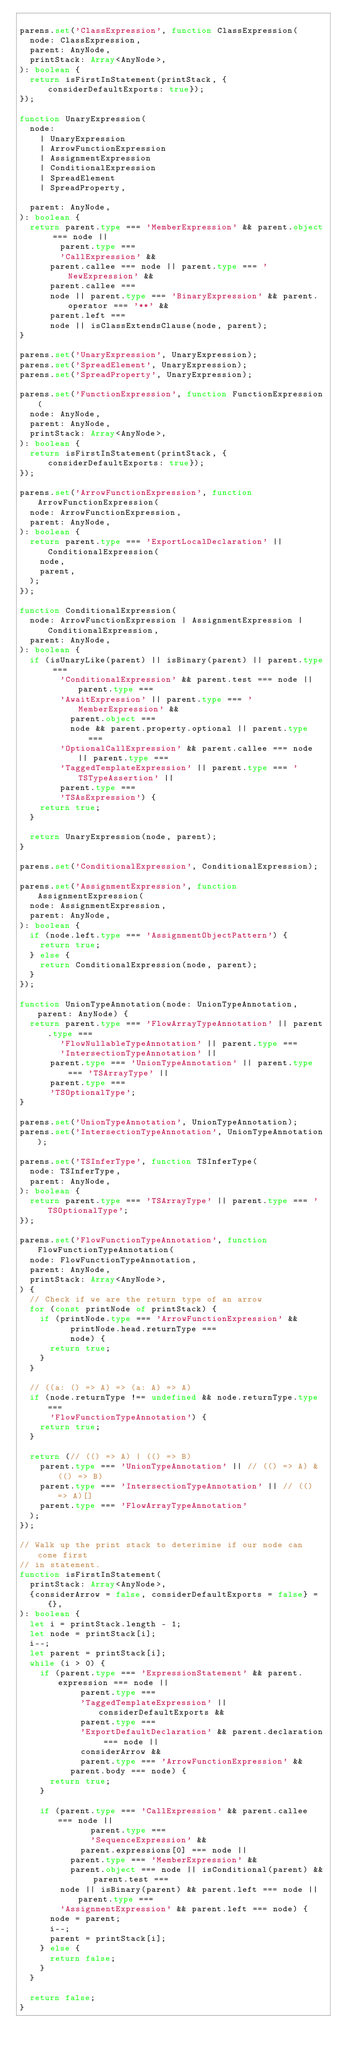Convert code to text. <code><loc_0><loc_0><loc_500><loc_500><_TypeScript_>
parens.set('ClassExpression', function ClassExpression(
  node: ClassExpression,
  parent: AnyNode,
  printStack: Array<AnyNode>,
): boolean {
  return isFirstInStatement(printStack, {considerDefaultExports: true});
});

function UnaryExpression(
  node:
    | UnaryExpression
    | ArrowFunctionExpression
    | AssignmentExpression
    | ConditionalExpression
    | SpreadElement
    | SpreadProperty,

  parent: AnyNode,
): boolean {
  return parent.type === 'MemberExpression' && parent.object === node ||
        parent.type ===
        'CallExpression' &&
      parent.callee === node || parent.type === 'NewExpression' &&
      parent.callee ===
      node || parent.type === 'BinaryExpression' && parent.operator === '**' &&
      parent.left ===
      node || isClassExtendsClause(node, parent);
}

parens.set('UnaryExpression', UnaryExpression);
parens.set('SpreadElement', UnaryExpression);
parens.set('SpreadProperty', UnaryExpression);

parens.set('FunctionExpression', function FunctionExpression(
  node: AnyNode,
  parent: AnyNode,
  printStack: Array<AnyNode>,
): boolean {
  return isFirstInStatement(printStack, {considerDefaultExports: true});
});

parens.set('ArrowFunctionExpression', function ArrowFunctionExpression(
  node: ArrowFunctionExpression,
  parent: AnyNode,
): boolean {
  return parent.type === 'ExportLocalDeclaration' || ConditionalExpression(
    node,
    parent,
  );
});

function ConditionalExpression(
  node: ArrowFunctionExpression | AssignmentExpression | ConditionalExpression,
  parent: AnyNode,
): boolean {
  if (isUnaryLike(parent) || isBinary(parent) || parent.type ===
        'ConditionalExpression' && parent.test === node || parent.type ===
        'AwaitExpression' || parent.type === 'MemberExpression' &&
          parent.object ===
          node && parent.property.optional || parent.type ===
        'OptionalCallExpression' && parent.callee === node || parent.type ===
        'TaggedTemplateExpression' || parent.type === 'TSTypeAssertion' ||
        parent.type ===
        'TSAsExpression') {
    return true;
  }

  return UnaryExpression(node, parent);
}

parens.set('ConditionalExpression', ConditionalExpression);

parens.set('AssignmentExpression', function AssignmentExpression(
  node: AssignmentExpression,
  parent: AnyNode,
): boolean {
  if (node.left.type === 'AssignmentObjectPattern') {
    return true;
  } else {
    return ConditionalExpression(node, parent);
  }
});

function UnionTypeAnnotation(node: UnionTypeAnnotation, parent: AnyNode) {
  return parent.type === 'FlowArrayTypeAnnotation' || parent.type ===
        'FlowNullableTypeAnnotation' || parent.type ===
        'IntersectionTypeAnnotation' ||
      parent.type === 'UnionTypeAnnotation' || parent.type === 'TSArrayType' ||
      parent.type ===
      'TSOptionalType';
}

parens.set('UnionTypeAnnotation', UnionTypeAnnotation);
parens.set('IntersectionTypeAnnotation', UnionTypeAnnotation);

parens.set('TSInferType', function TSInferType(
  node: TSInferType,
  parent: AnyNode,
): boolean {
  return parent.type === 'TSArrayType' || parent.type === 'TSOptionalType';
});

parens.set('FlowFunctionTypeAnnotation', function FlowFunctionTypeAnnotation(
  node: FlowFunctionTypeAnnotation,
  parent: AnyNode,
  printStack: Array<AnyNode>,
) {
  // Check if we are the return type of an arrow
  for (const printNode of printStack) {
    if (printNode.type === 'ArrowFunctionExpression' &&
          printNode.head.returnType ===
          node) {
      return true;
    }
  }

  // ((a: () => A) => (a: A) => A)
  if (node.returnType !== undefined && node.returnType.type ===
      'FlowFunctionTypeAnnotation') {
    return true;
  }

  return (// (() => A) | (() => B)
    parent.type === 'UnionTypeAnnotation' || // (() => A) & (() => B)
    parent.type === 'IntersectionTypeAnnotation' || // (() => A)[]
    parent.type === 'FlowArrayTypeAnnotation'
  );
});

// Walk up the print stack to deterimine if our node can come first
// in statement.
function isFirstInStatement(
  printStack: Array<AnyNode>,
  {considerArrow = false, considerDefaultExports = false} = {},
): boolean {
  let i = printStack.length - 1;
  let node = printStack[i];
  i--;
  let parent = printStack[i];
  while (i > 0) {
    if (parent.type === 'ExpressionStatement' && parent.expression === node ||
            parent.type ===
            'TaggedTemplateExpression' || considerDefaultExports &&
            parent.type ===
            'ExportDefaultDeclaration' && parent.declaration === node ||
            considerArrow &&
            parent.type === 'ArrowFunctionExpression' &&
          parent.body === node) {
      return true;
    }

    if (parent.type === 'CallExpression' && parent.callee === node ||
              parent.type ===
              'SequenceExpression' &&
            parent.expressions[0] === node ||
          parent.type === 'MemberExpression' &&
          parent.object === node || isConditional(parent) && parent.test ===
        node || isBinary(parent) && parent.left === node || parent.type ===
        'AssignmentExpression' && parent.left === node) {
      node = parent;
      i--;
      parent = printStack[i];
    } else {
      return false;
    }
  }

  return false;
}
</code> 